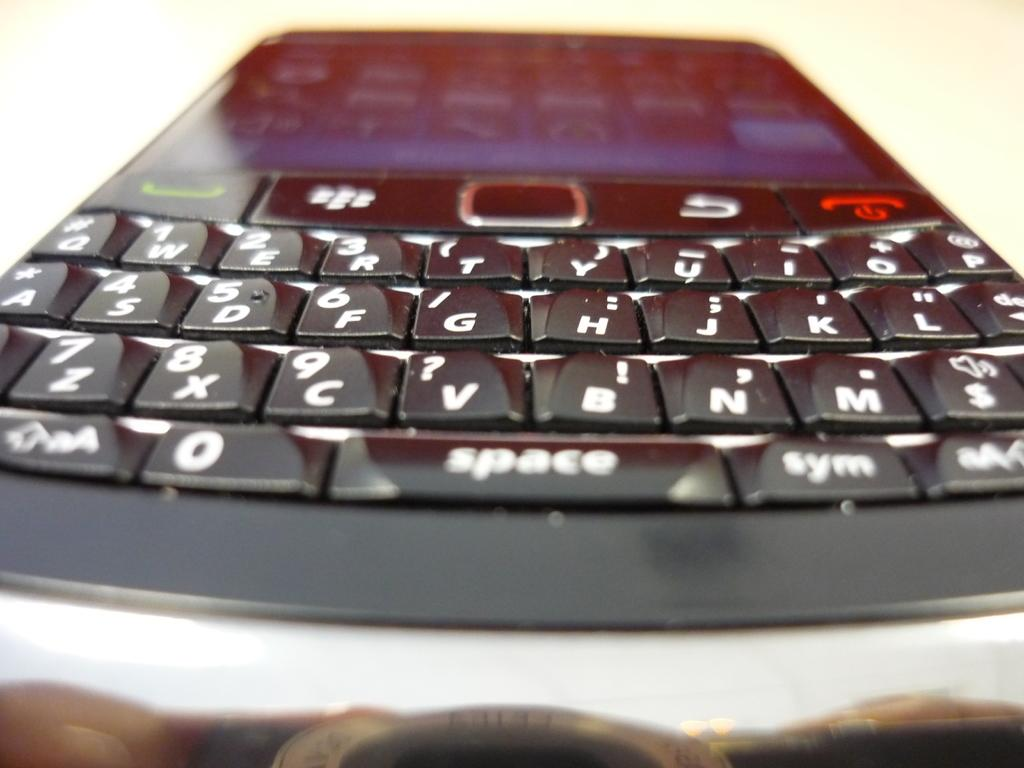What electronic device is visible in the image? There is a mobile phone in the image. What feature is present on the mobile phone? The mobile phone has a keypad. What color is the background of the image? The background of the image is white. What type of furniture can be seen in the image? There is no furniture present in the image; it only features a mobile phone with a keypad against a white background. 